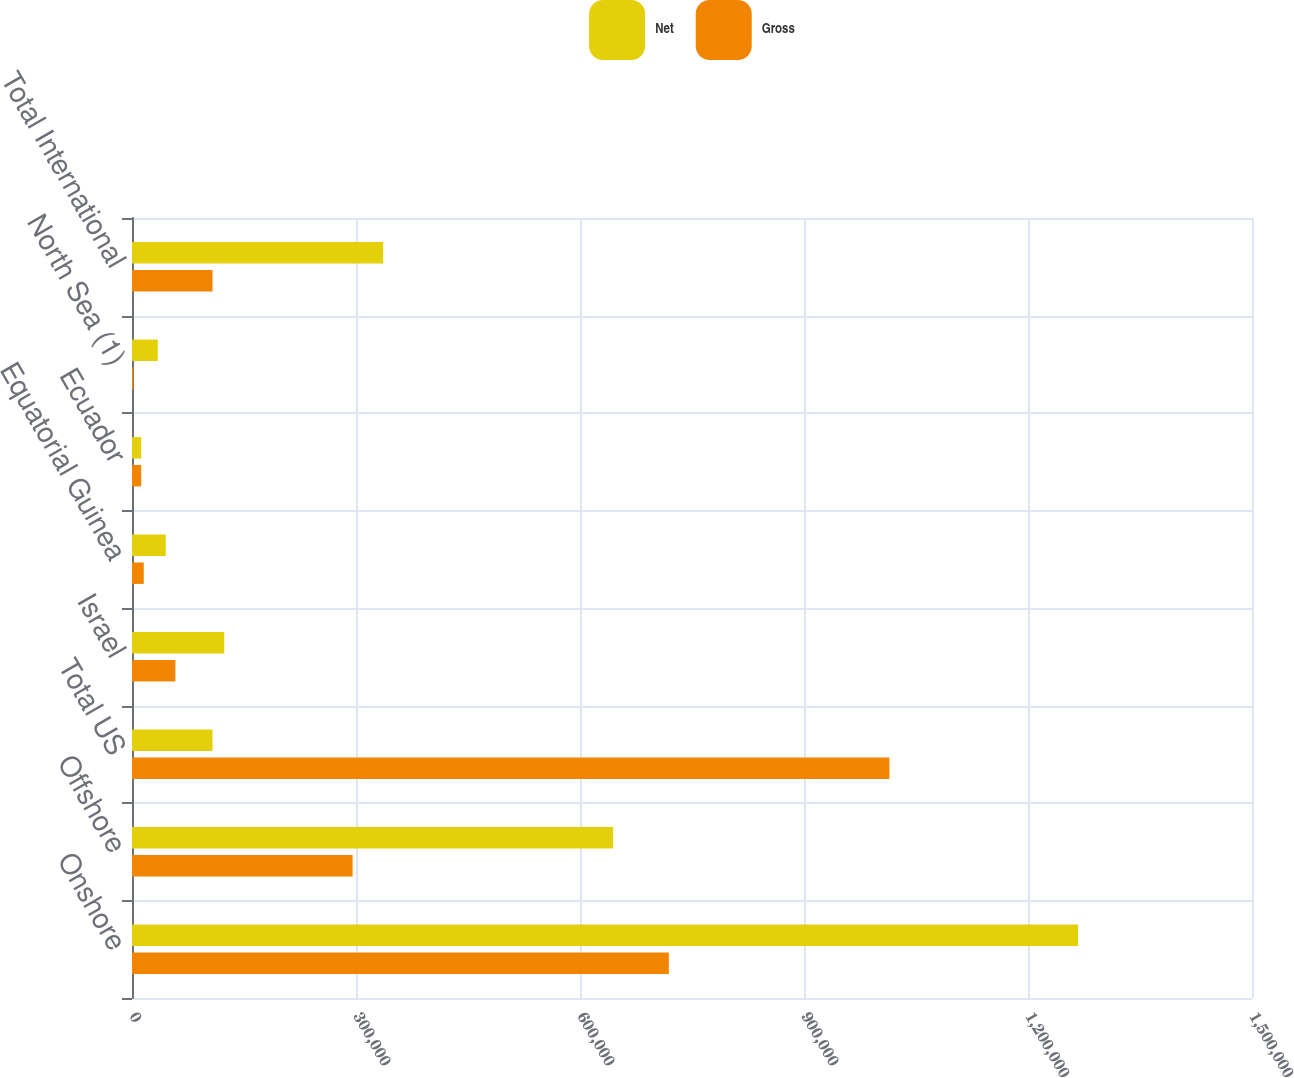<chart> <loc_0><loc_0><loc_500><loc_500><stacked_bar_chart><ecel><fcel>Onshore<fcel>Offshore<fcel>Total US<fcel>Israel<fcel>Equatorial Guinea<fcel>Ecuador<fcel>North Sea (1)<fcel>Total International<nl><fcel>Net<fcel>1.26705e+06<fcel>644454<fcel>107835<fcel>123552<fcel>45203<fcel>12355<fcel>34580<fcel>336428<nl><fcel>Gross<fcel>718997<fcel>295463<fcel>1.01446e+06<fcel>58142<fcel>15727<fcel>12355<fcel>1838<fcel>107835<nl></chart> 